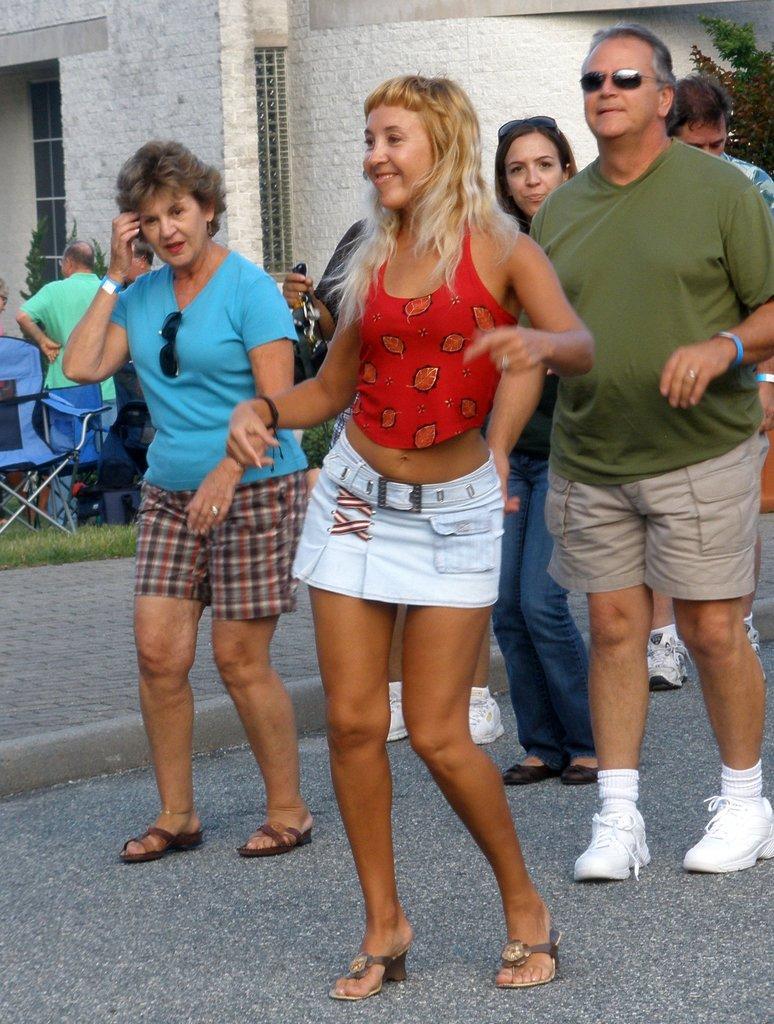Describe this image in one or two sentences. In this image I can see a woman wearing red and white colored dress and another woman wearing blue colored dress are standing on the ground and in the background I can see few other persons standing, some grass, few trees and the building which is cream in color. 